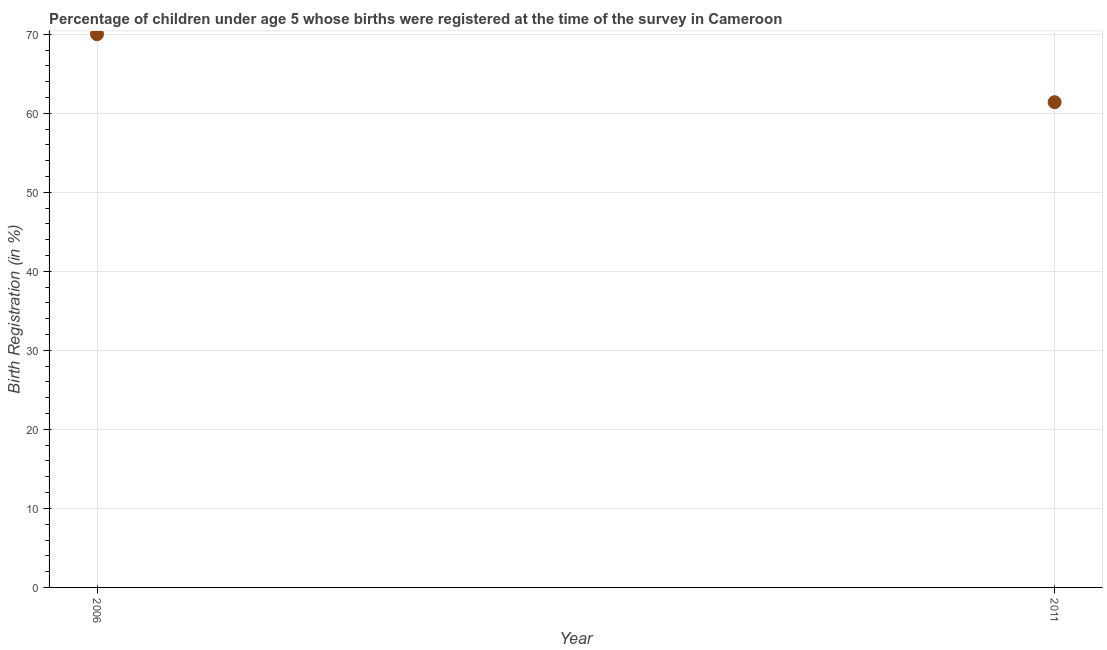What is the birth registration in 2011?
Provide a succinct answer. 61.4. Across all years, what is the minimum birth registration?
Make the answer very short. 61.4. In which year was the birth registration maximum?
Provide a short and direct response. 2006. What is the sum of the birth registration?
Offer a terse response. 131.4. What is the difference between the birth registration in 2006 and 2011?
Provide a short and direct response. 8.6. What is the average birth registration per year?
Your answer should be very brief. 65.7. What is the median birth registration?
Your answer should be very brief. 65.7. What is the ratio of the birth registration in 2006 to that in 2011?
Make the answer very short. 1.14. Is the birth registration in 2006 less than that in 2011?
Offer a very short reply. No. In how many years, is the birth registration greater than the average birth registration taken over all years?
Keep it short and to the point. 1. How many years are there in the graph?
Provide a succinct answer. 2. Are the values on the major ticks of Y-axis written in scientific E-notation?
Ensure brevity in your answer.  No. Does the graph contain any zero values?
Make the answer very short. No. What is the title of the graph?
Offer a terse response. Percentage of children under age 5 whose births were registered at the time of the survey in Cameroon. What is the label or title of the Y-axis?
Make the answer very short. Birth Registration (in %). What is the Birth Registration (in %) in 2006?
Make the answer very short. 70. What is the Birth Registration (in %) in 2011?
Your response must be concise. 61.4. What is the difference between the Birth Registration (in %) in 2006 and 2011?
Provide a succinct answer. 8.6. What is the ratio of the Birth Registration (in %) in 2006 to that in 2011?
Ensure brevity in your answer.  1.14. 